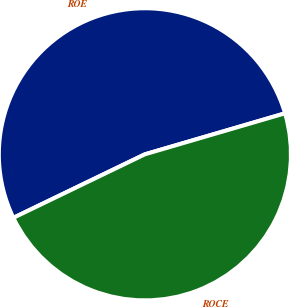Convert chart. <chart><loc_0><loc_0><loc_500><loc_500><pie_chart><fcel>ROE<fcel>ROCE<nl><fcel>52.63%<fcel>47.37%<nl></chart> 